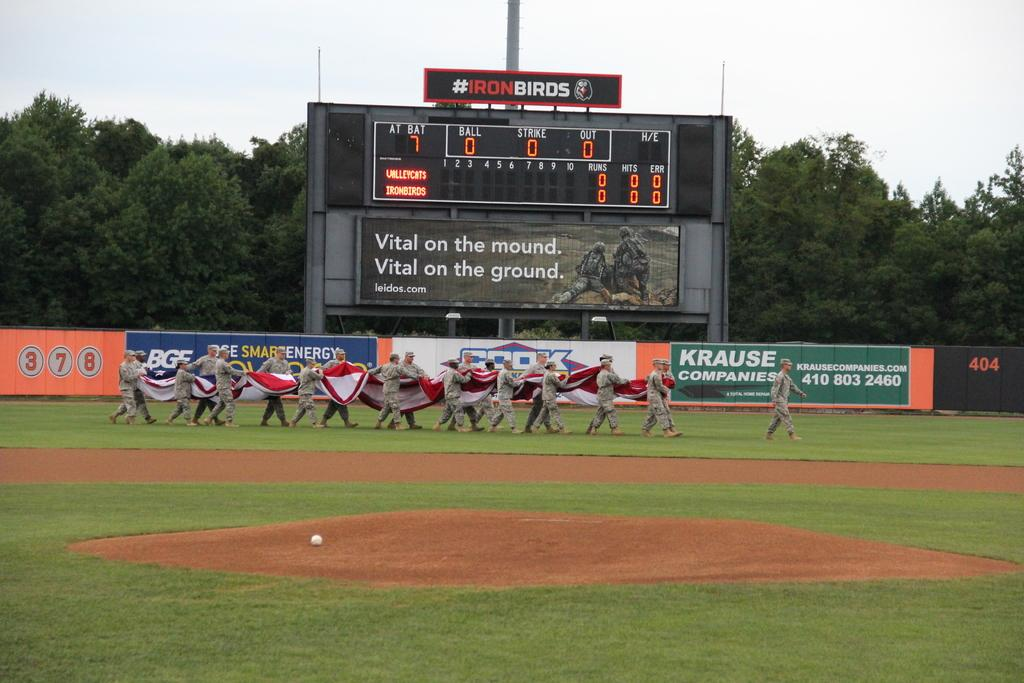Provide a one-sentence caption for the provided image. The outfield fence of a baseball stadium features an advertisement for Krause Companies. 